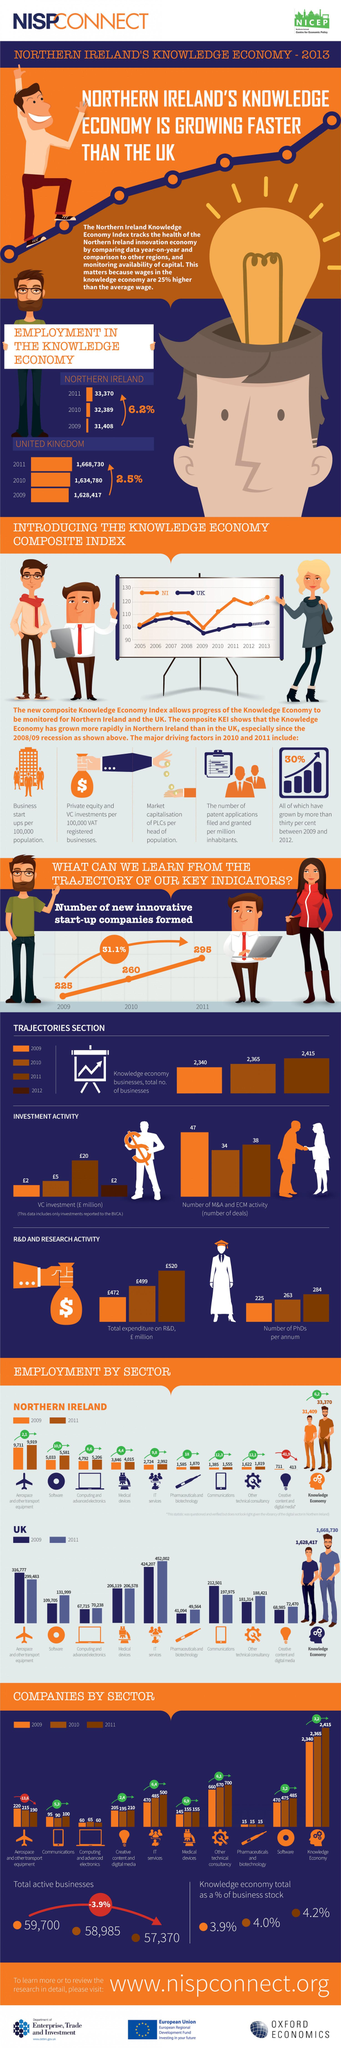Identify some key points in this picture. The employment rate of the UK's software sector in 2011 was higher than in 2009. The employment rate in the software sector in Northern Ireland in 2011 was higher than in 2009. The employment rate of the IT sector in Northern Ireland in 2011 was significantly higher compared to 2009. In 2011, there were 25 more businesses compared to 2009. 